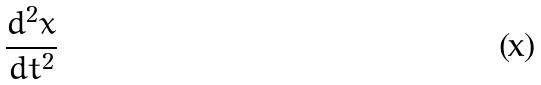<formula> <loc_0><loc_0><loc_500><loc_500>\frac { d ^ { 2 } x } { d t ^ { 2 } }</formula> 